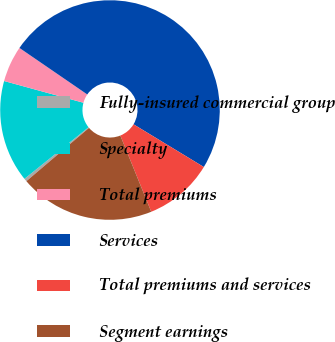Convert chart. <chart><loc_0><loc_0><loc_500><loc_500><pie_chart><fcel>Fully-insured commercial group<fcel>Specialty<fcel>Total premiums<fcel>Services<fcel>Total premiums and services<fcel>Segment earnings<nl><fcel>0.44%<fcel>15.04%<fcel>5.31%<fcel>49.12%<fcel>10.18%<fcel>19.91%<nl></chart> 